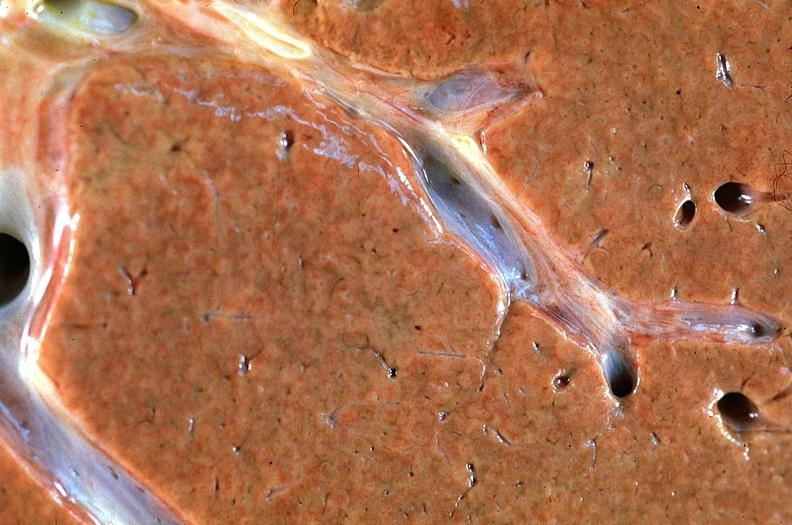does good example of muscle atrophy show normal liver?
Answer the question using a single word or phrase. No 